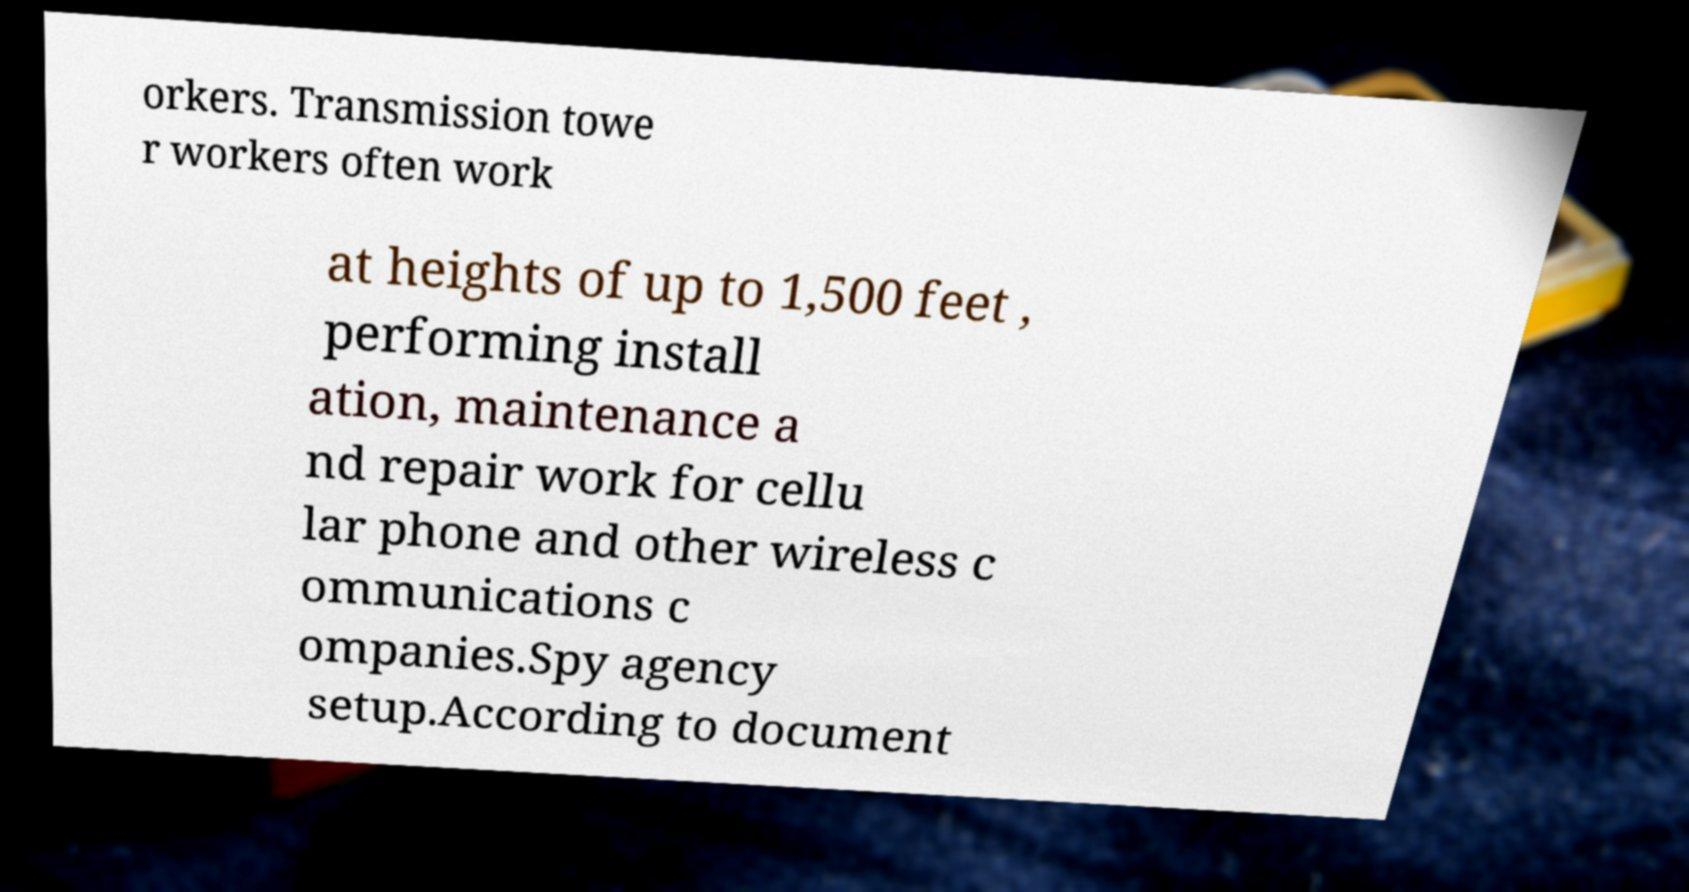For documentation purposes, I need the text within this image transcribed. Could you provide that? orkers. Transmission towe r workers often work at heights of up to 1,500 feet , performing install ation, maintenance a nd repair work for cellu lar phone and other wireless c ommunications c ompanies.Spy agency setup.According to document 